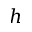Convert formula to latex. <formula><loc_0><loc_0><loc_500><loc_500>h</formula> 